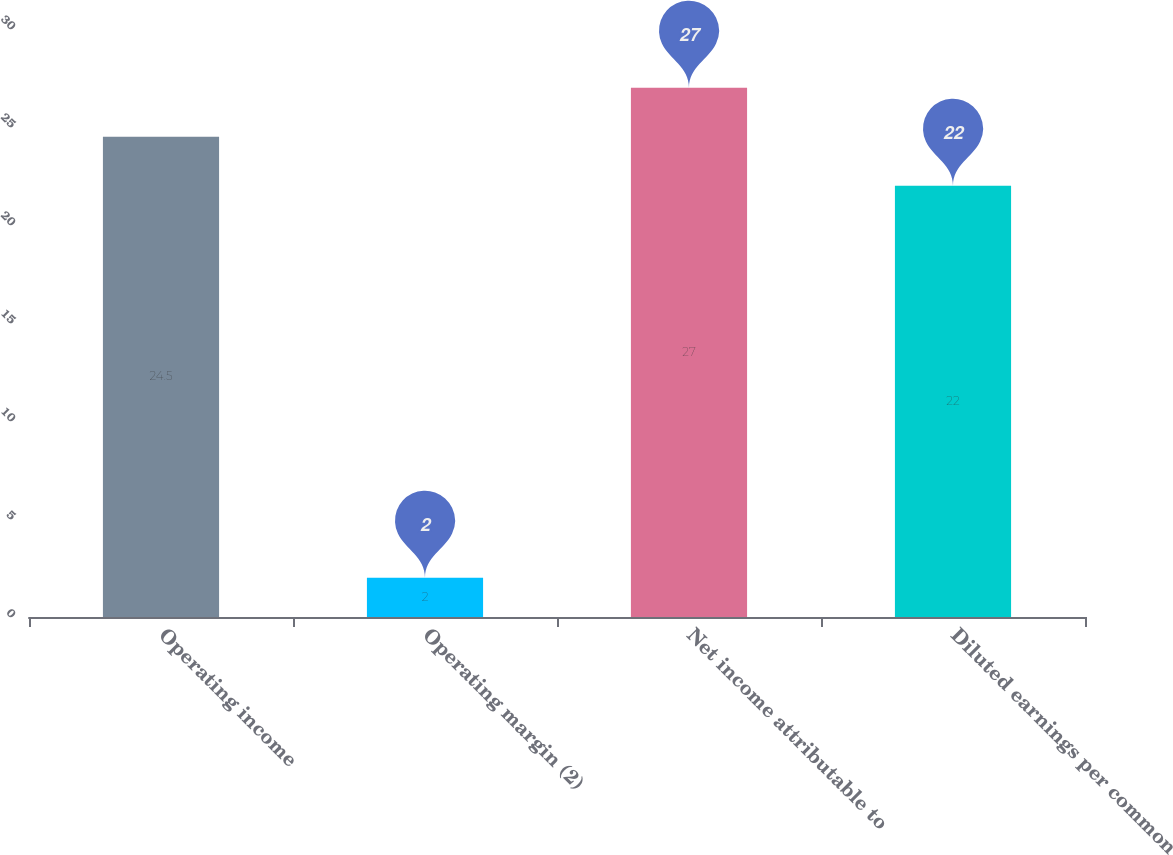Convert chart. <chart><loc_0><loc_0><loc_500><loc_500><bar_chart><fcel>Operating income<fcel>Operating margin (2)<fcel>Net income attributable to<fcel>Diluted earnings per common<nl><fcel>24.5<fcel>2<fcel>27<fcel>22<nl></chart> 